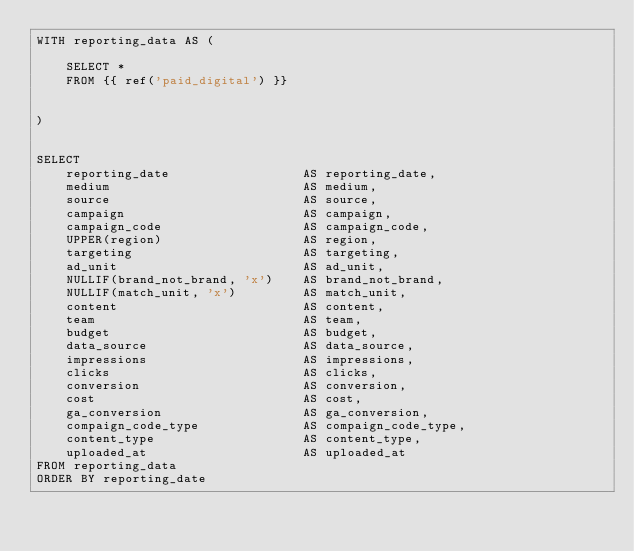Convert code to text. <code><loc_0><loc_0><loc_500><loc_500><_SQL_>WITH reporting_data AS (

    SELECT *
    FROM {{ ref('paid_digital') }}


)


SELECT
    reporting_date                  AS reporting_date,
    medium                          AS medium,
    source                          AS source,
    campaign                        AS campaign,
    campaign_code                   AS campaign_code,
    UPPER(region)                   AS region,
    targeting                       AS targeting,
    ad_unit                         AS ad_unit,
    NULLIF(brand_not_brand, 'x')    AS brand_not_brand,
    NULLIF(match_unit, 'x')         AS match_unit,
    content                         AS content,
    team                            AS team,
    budget                          AS budget,
    data_source                     AS data_source,
    impressions                     AS impressions,
    clicks                          AS clicks,
    conversion                      AS conversion,
    cost                            AS cost,
    ga_conversion                   AS ga_conversion,
    compaign_code_type              AS compaign_code_type,
    content_type                    AS content_type,
    uploaded_at                     AS uploaded_at
FROM reporting_data
ORDER BY reporting_date
</code> 